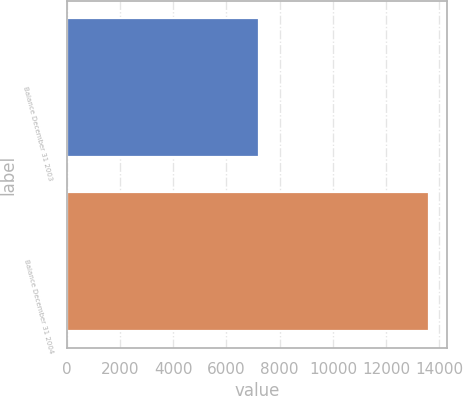Convert chart. <chart><loc_0><loc_0><loc_500><loc_500><bar_chart><fcel>Balance December 31 2003<fcel>Balance December 31 2004<nl><fcel>7227<fcel>13617<nl></chart> 